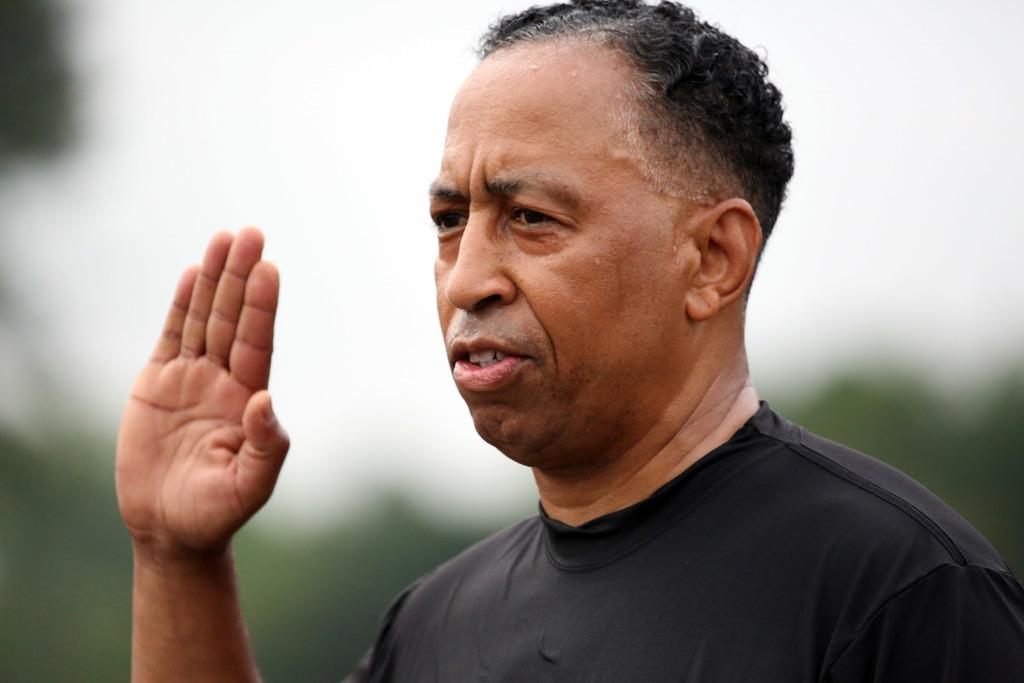Who is present in the image? There is a man in the image. What is the man doing with his hand? The man is raising his hand. What color are the clothes the man is wearing? The man is wearing black color clothes. Can you describe the background of the image? The background of the image is blurred. What type of birds can be seen flying in the image? There are no birds visible in the image. What is the man using to control the speed of his vehicle in the image? The image does not show the man controlling a vehicle, so there is no brake or cord present. 